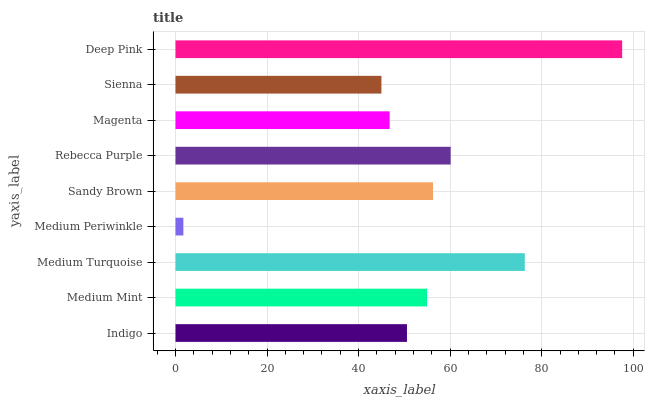Is Medium Periwinkle the minimum?
Answer yes or no. Yes. Is Deep Pink the maximum?
Answer yes or no. Yes. Is Medium Mint the minimum?
Answer yes or no. No. Is Medium Mint the maximum?
Answer yes or no. No. Is Medium Mint greater than Indigo?
Answer yes or no. Yes. Is Indigo less than Medium Mint?
Answer yes or no. Yes. Is Indigo greater than Medium Mint?
Answer yes or no. No. Is Medium Mint less than Indigo?
Answer yes or no. No. Is Medium Mint the high median?
Answer yes or no. Yes. Is Medium Mint the low median?
Answer yes or no. Yes. Is Medium Periwinkle the high median?
Answer yes or no. No. Is Sienna the low median?
Answer yes or no. No. 